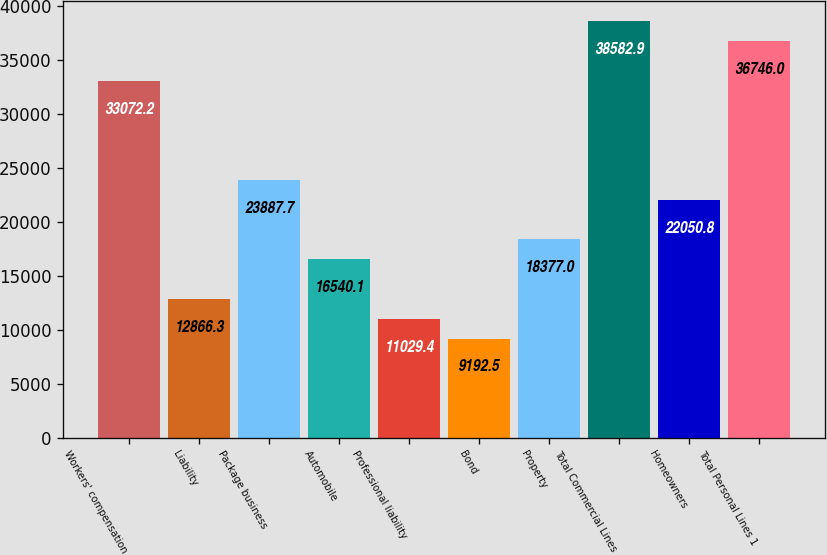Convert chart. <chart><loc_0><loc_0><loc_500><loc_500><bar_chart><fcel>Workers' compensation<fcel>Liability<fcel>Package business<fcel>Automobile<fcel>Professional liability<fcel>Bond<fcel>Property<fcel>Total Commercial Lines<fcel>Homeowners<fcel>Total Personal Lines 1<nl><fcel>33072.2<fcel>12866.3<fcel>23887.7<fcel>16540.1<fcel>11029.4<fcel>9192.5<fcel>18377<fcel>38582.9<fcel>22050.8<fcel>36746<nl></chart> 